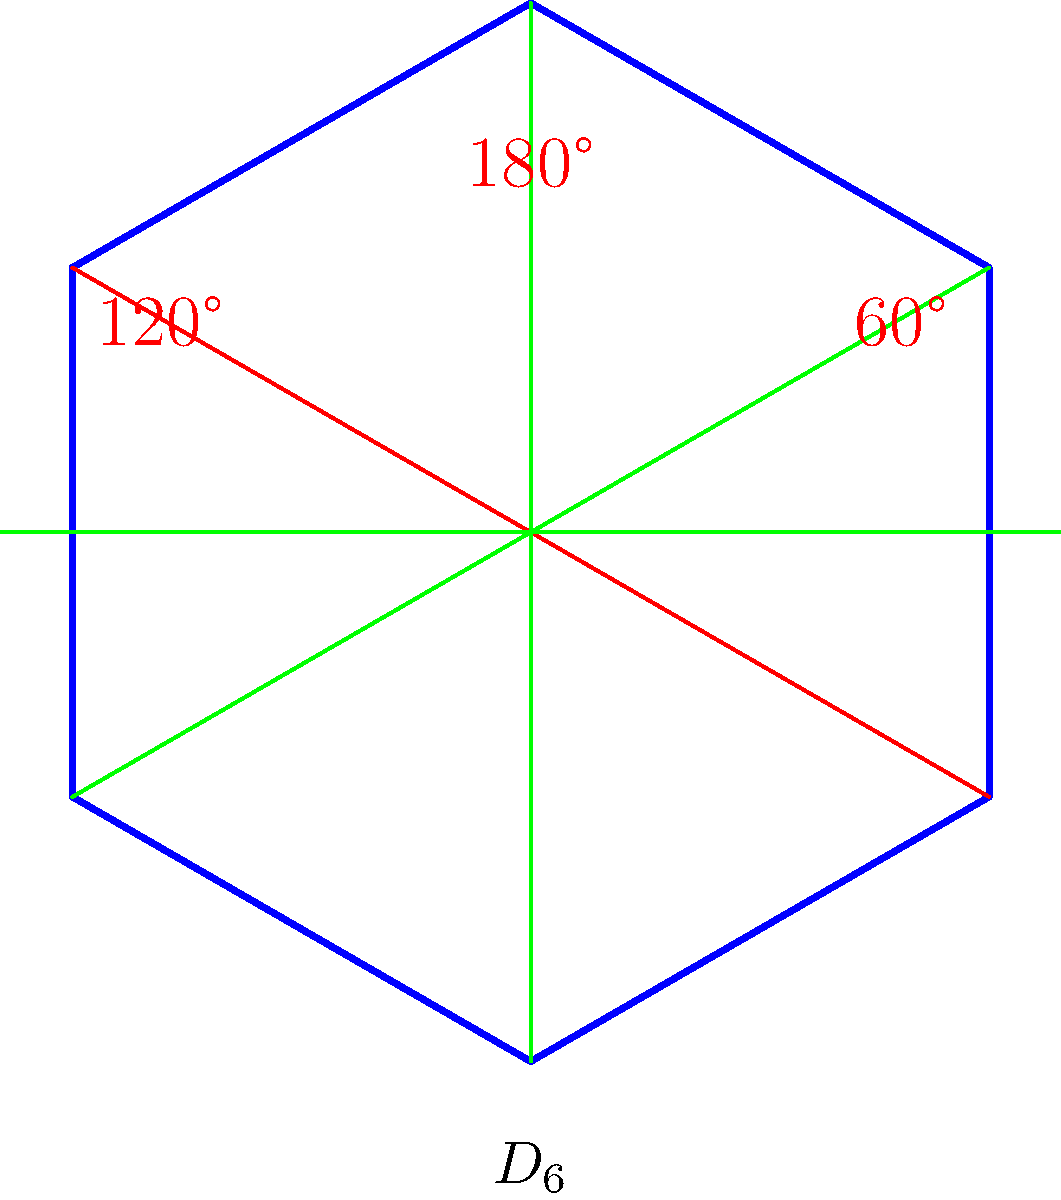In the trendy geometric installation shown above, which represents a hexagonal pattern commonly found in modern art, what is the order of the dihedral group $D_6$ that describes its symmetries? To determine the order of the dihedral group $D_6$, we need to follow these steps:

1. Recall that the dihedral group $D_n$ is the group of symmetries of a regular n-gon.

2. In this case, we have a hexagon, so $n = 6$.

3. The order of $D_n$ is given by the formula: $|D_n| = 2n$

4. For $D_6$, we have:
   $|D_6| = 2 \cdot 6 = 12$

5. We can verify this by counting the symmetries:
   - 6 rotational symmetries (including the identity rotation):
     0°, 60°, 120°, 180°, 240°, 300°
   - 6 reflection symmetries (across the 3 diagonals and 3 medians)

6. The total number of symmetries is indeed 6 + 6 = 12.

Therefore, the order of the dihedral group $D_6$ is 12.
Answer: 12 